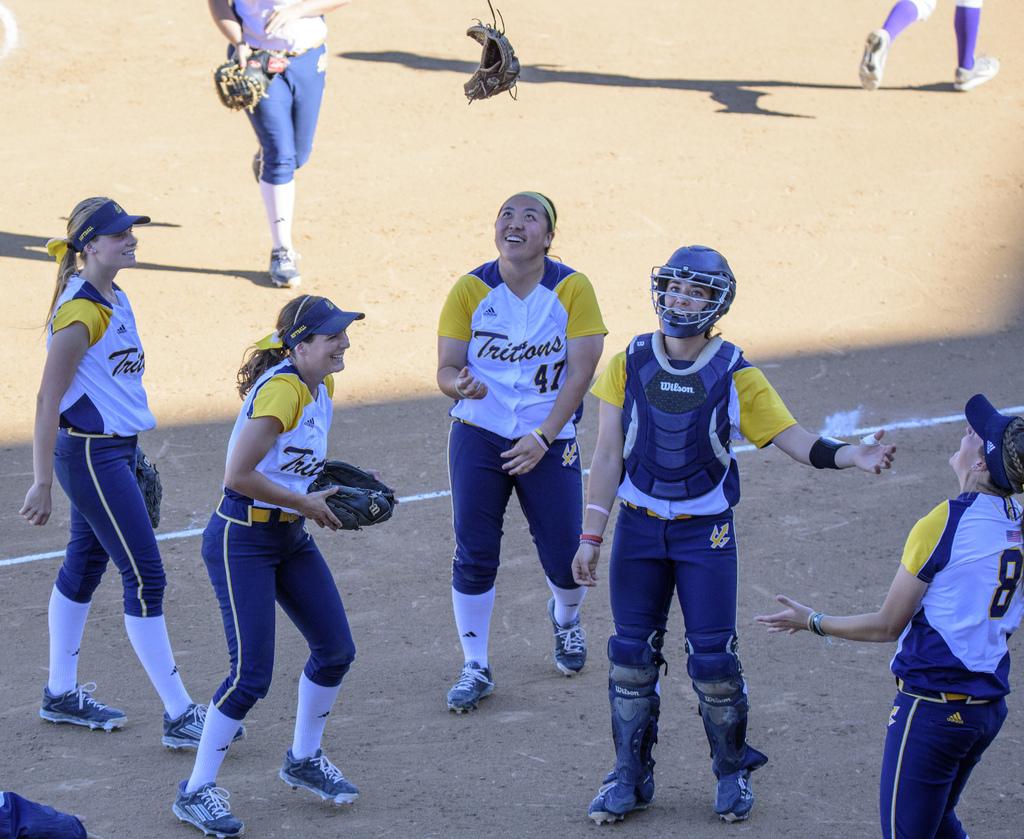What number is the player in the middle?
Your response must be concise. 47. 